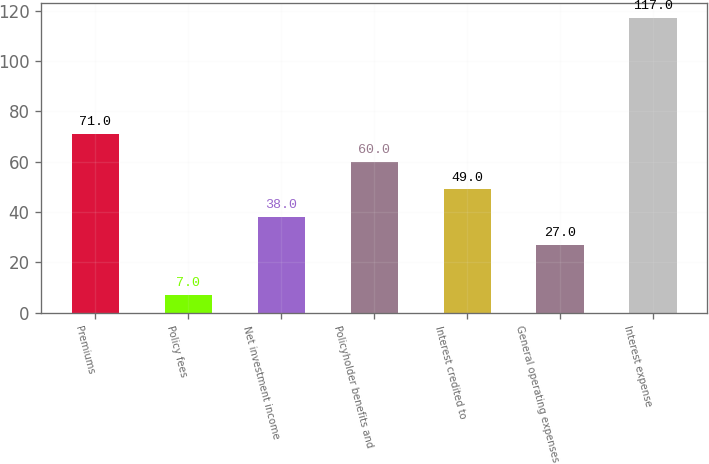Convert chart. <chart><loc_0><loc_0><loc_500><loc_500><bar_chart><fcel>Premiums<fcel>Policy fees<fcel>Net investment income<fcel>Policyholder benefits and<fcel>Interest credited to<fcel>General operating expenses<fcel>Interest expense<nl><fcel>71<fcel>7<fcel>38<fcel>60<fcel>49<fcel>27<fcel>117<nl></chart> 